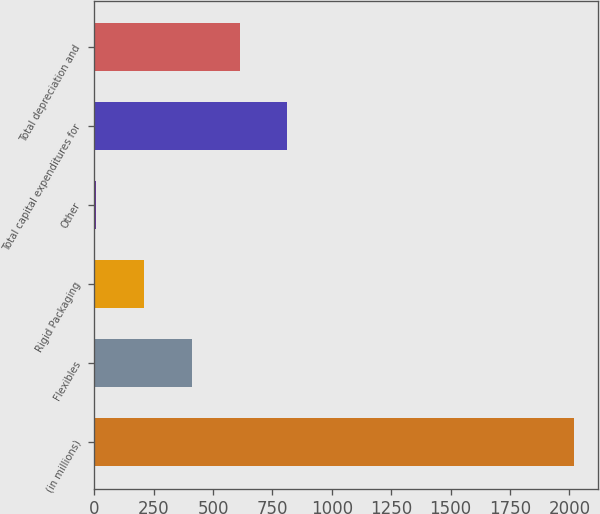Convert chart. <chart><loc_0><loc_0><loc_500><loc_500><bar_chart><fcel>(in millions)<fcel>Flexibles<fcel>Rigid Packaging<fcel>Other<fcel>Total capital expenditures for<fcel>Total depreciation and<nl><fcel>2018<fcel>410.8<fcel>209.9<fcel>9<fcel>812.6<fcel>611.7<nl></chart> 